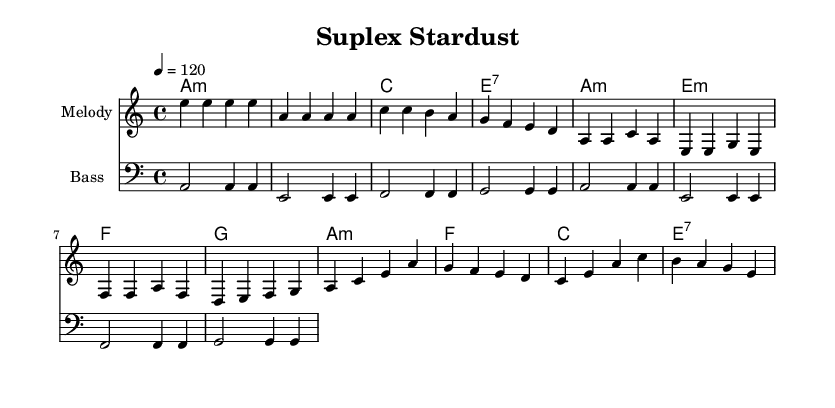What is the key signature of this music? The key signature is A minor, which has no sharps or flats.
Answer: A minor What is the time signature of this music? The time signature shown in the sheet music is 4/4, meaning there are four beats in each measure.
Answer: 4/4 What is the tempo marking in this music? The tempo marking indicates a speed of quarter note equals 120 beats per minute, providing a lively disco feel.
Answer: 120 How many measures are in the verse section? The verse section consists of four measures as indicated by the arrangement of notes.
Answer: 4 Which chord is used in the chorus? The chorus features an A minor chord prominently, as indicated in the chord changes.
Answer: A minor What type of instrument is indicated in the melody staff? The staff for melody suggests it is for an instrument typically used in disco music, such as a synthesizer or electric keyboard.
Answer: Melody What overall theme can be inferred from the title "Suplex Stardust"? The title suggests a blend of wrestling imagery and cosmic elements, indicative of larger-than-life personalities typical in disco anthems.
Answer: Heroic narrative 